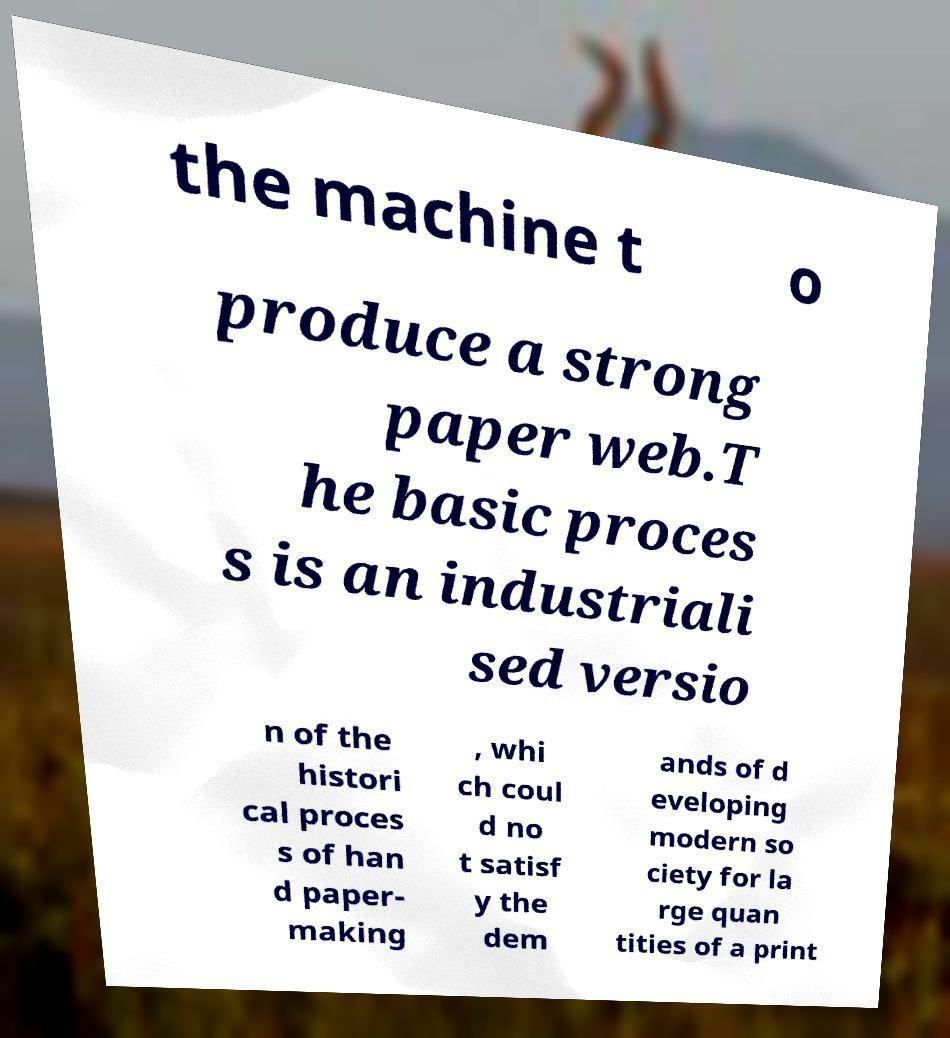I need the written content from this picture converted into text. Can you do that? the machine t o produce a strong paper web.T he basic proces s is an industriali sed versio n of the histori cal proces s of han d paper- making , whi ch coul d no t satisf y the dem ands of d eveloping modern so ciety for la rge quan tities of a print 